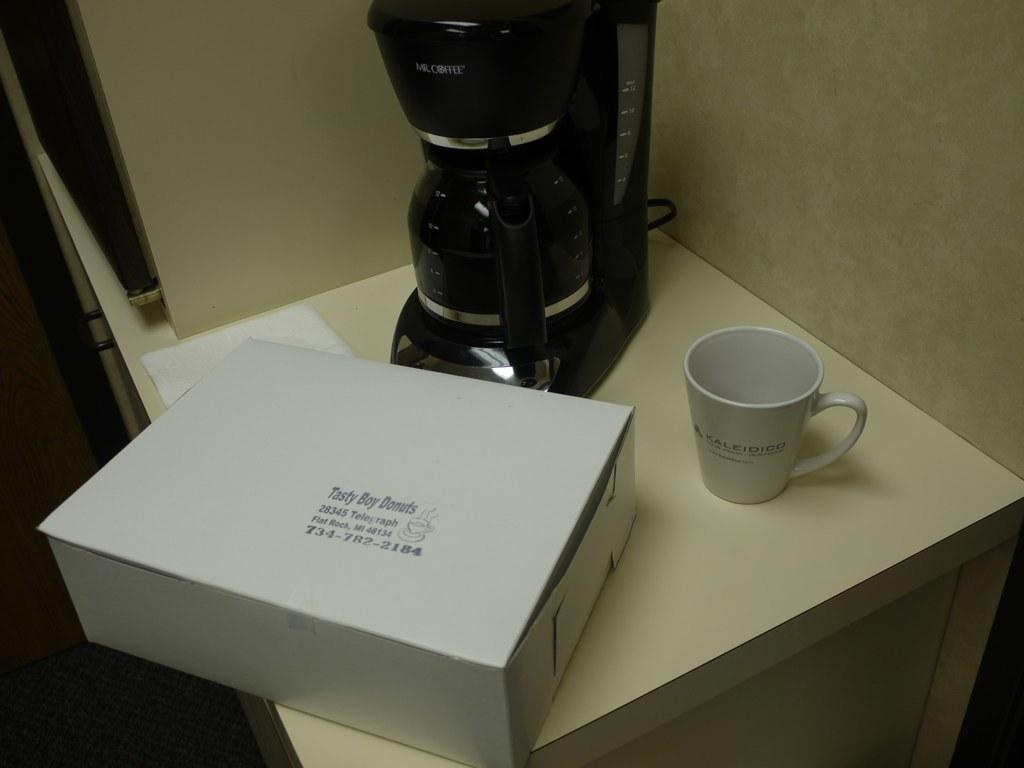<image>
Offer a succinct explanation of the picture presented. A box of Tasty Boy Donuts sits next to a coffee maker and a coffee cup. 